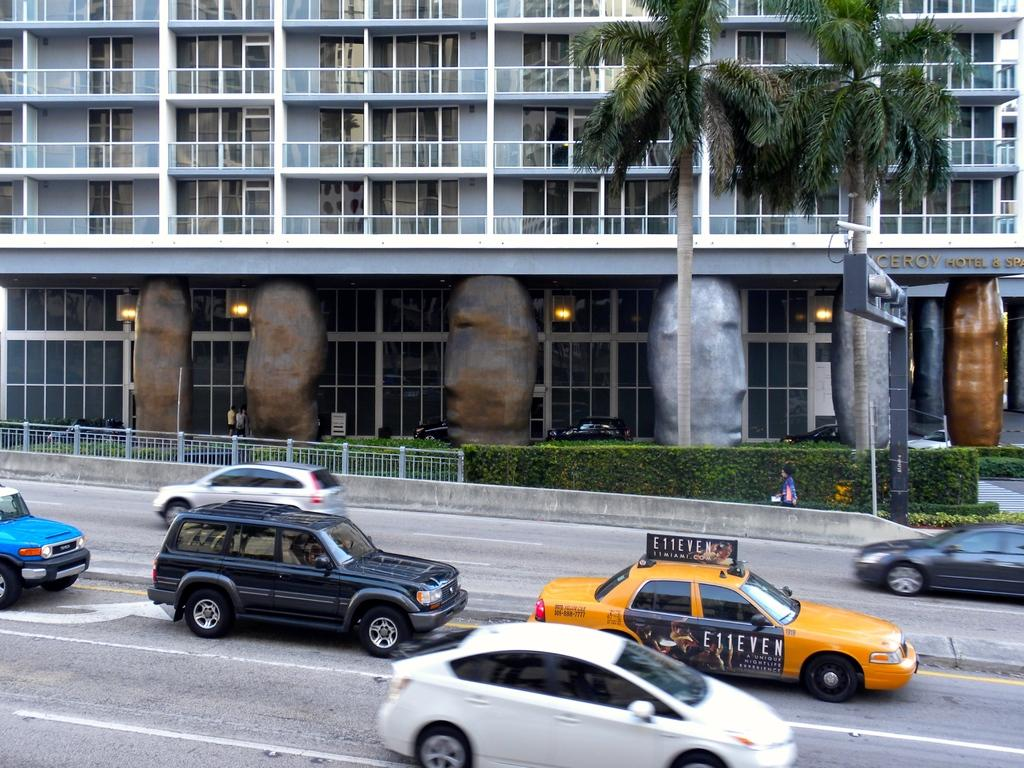<image>
Create a compact narrative representing the image presented. A taxi cab in a large city advertises for E11EVEN. 